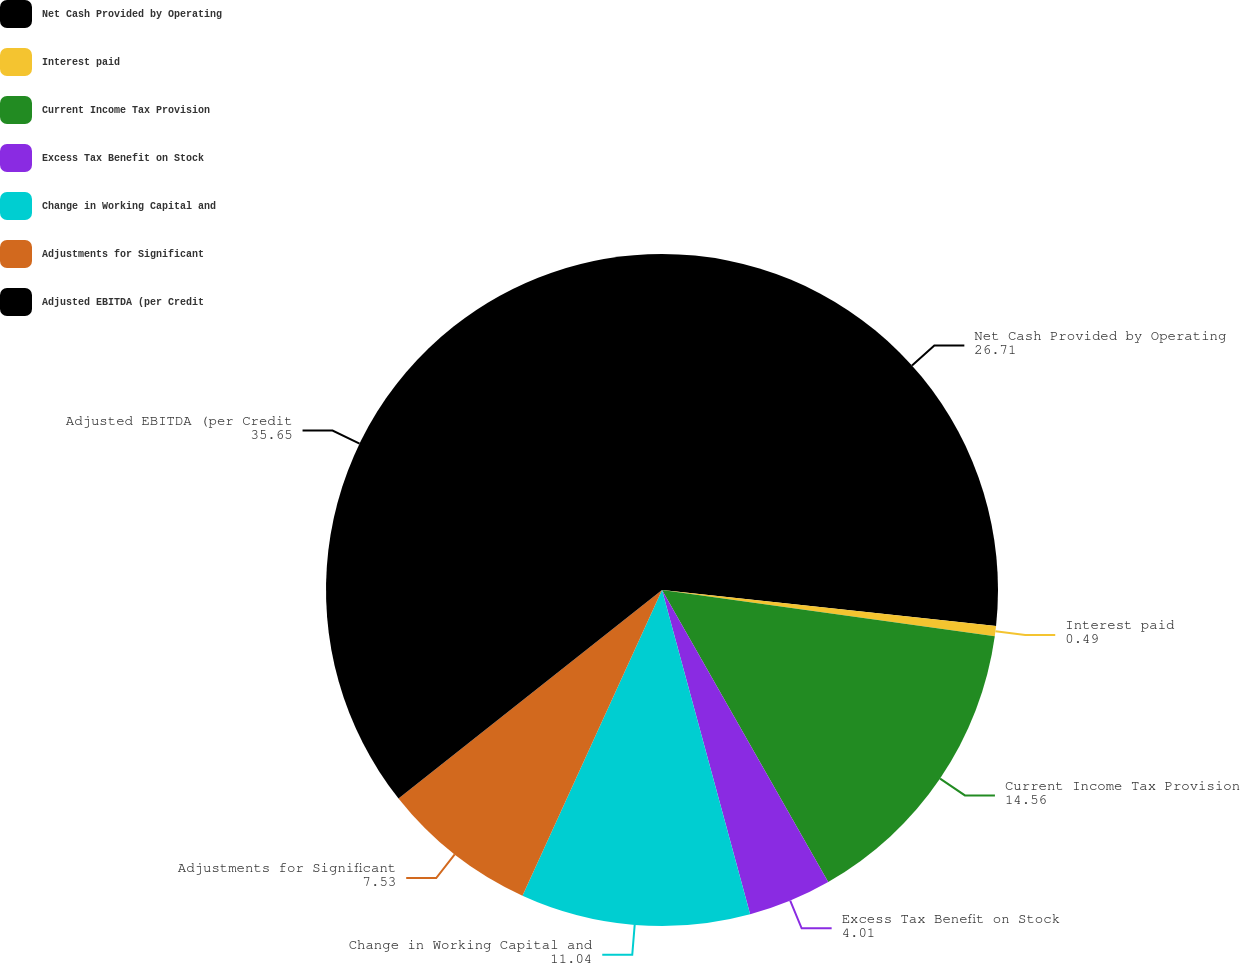<chart> <loc_0><loc_0><loc_500><loc_500><pie_chart><fcel>Net Cash Provided by Operating<fcel>Interest paid<fcel>Current Income Tax Provision<fcel>Excess Tax Benefit on Stock<fcel>Change in Working Capital and<fcel>Adjustments for Significant<fcel>Adjusted EBITDA (per Credit<nl><fcel>26.71%<fcel>0.49%<fcel>14.56%<fcel>4.01%<fcel>11.04%<fcel>7.53%<fcel>35.65%<nl></chart> 